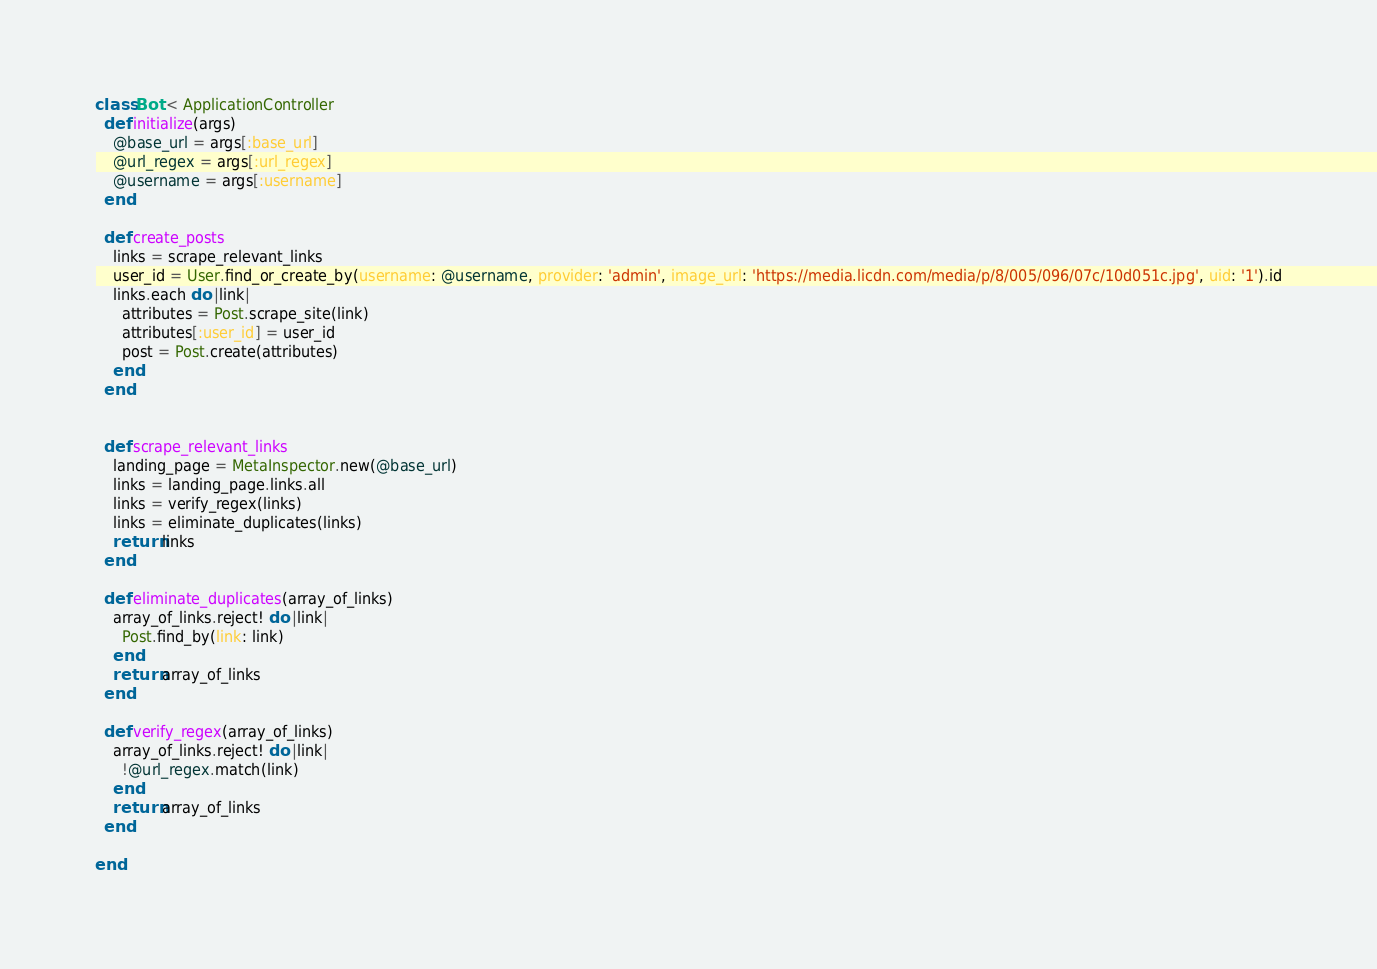Convert code to text. <code><loc_0><loc_0><loc_500><loc_500><_Ruby_>
class Bot < ApplicationController
  def initialize(args)
    @base_url = args[:base_url]
    @url_regex = args[:url_regex]
    @username = args[:username]
  end

  def create_posts
    links = scrape_relevant_links
    user_id = User.find_or_create_by(username: @username, provider: 'admin', image_url: 'https://media.licdn.com/media/p/8/005/096/07c/10d051c.jpg', uid: '1').id
    links.each do |link|
      attributes = Post.scrape_site(link)
      attributes[:user_id] = user_id
      post = Post.create(attributes)
    end
  end


  def scrape_relevant_links
    landing_page = MetaInspector.new(@base_url)
    links = landing_page.links.all
    links = verify_regex(links)
    links = eliminate_duplicates(links)
    return links
  end

  def eliminate_duplicates(array_of_links)
    array_of_links.reject! do |link|
      Post.find_by(link: link)
    end
    return array_of_links
  end

  def verify_regex(array_of_links)
    array_of_links.reject! do |link|
      !@url_regex.match(link)
    end
    return array_of_links
  end

end</code> 